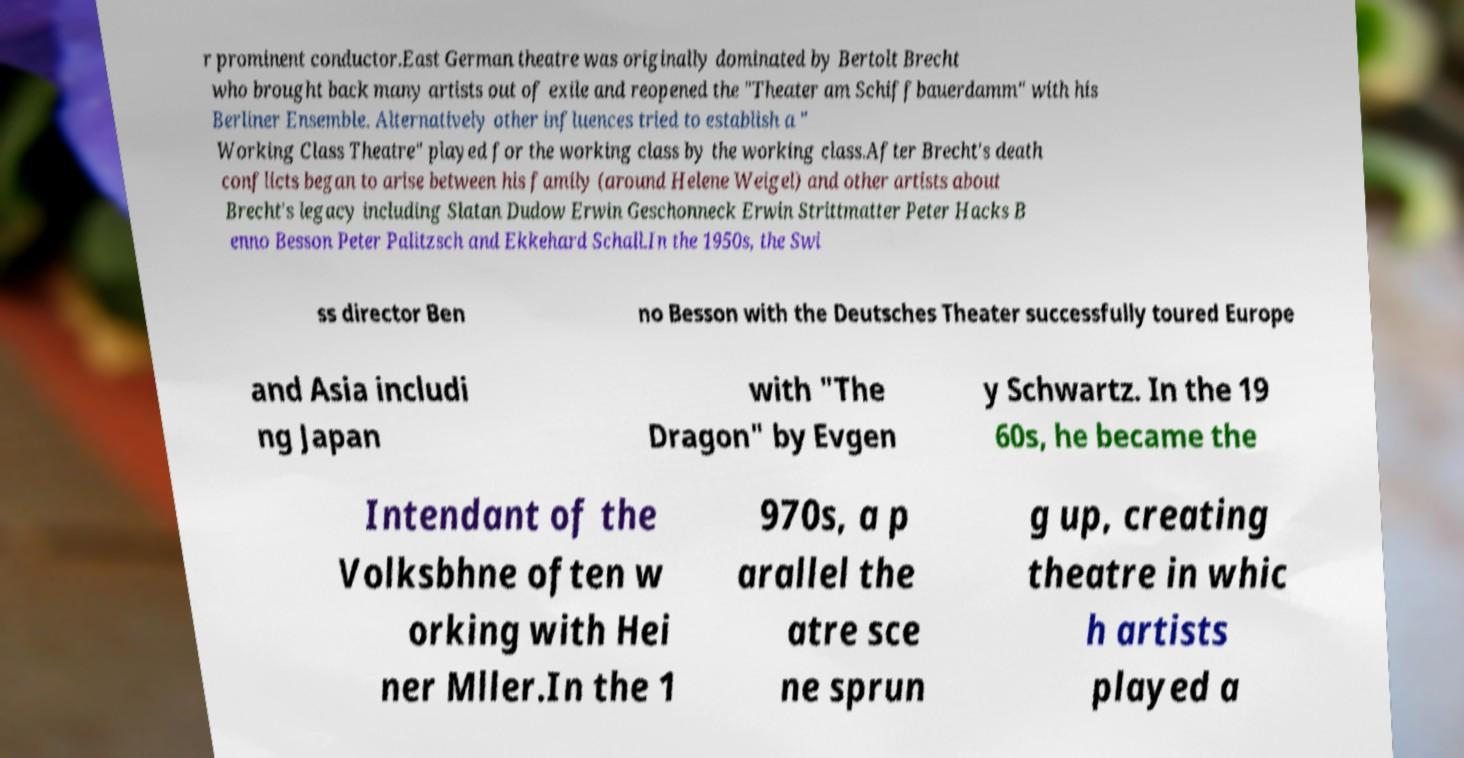Please read and relay the text visible in this image. What does it say? r prominent conductor.East German theatre was originally dominated by Bertolt Brecht who brought back many artists out of exile and reopened the "Theater am Schiffbauerdamm" with his Berliner Ensemble. Alternatively other influences tried to establish a " Working Class Theatre" played for the working class by the working class.After Brecht's death conflicts began to arise between his family (around Helene Weigel) and other artists about Brecht's legacy including Slatan Dudow Erwin Geschonneck Erwin Strittmatter Peter Hacks B enno Besson Peter Palitzsch and Ekkehard Schall.In the 1950s, the Swi ss director Ben no Besson with the Deutsches Theater successfully toured Europe and Asia includi ng Japan with "The Dragon" by Evgen y Schwartz. In the 19 60s, he became the Intendant of the Volksbhne often w orking with Hei ner Mller.In the 1 970s, a p arallel the atre sce ne sprun g up, creating theatre in whic h artists played a 